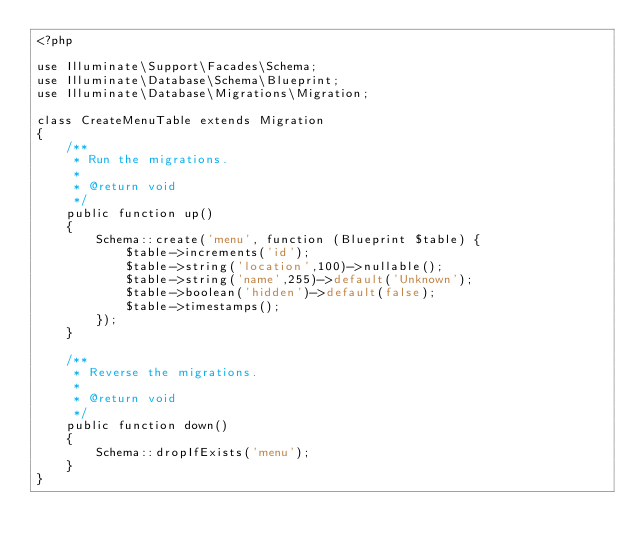Convert code to text. <code><loc_0><loc_0><loc_500><loc_500><_PHP_><?php

use Illuminate\Support\Facades\Schema;
use Illuminate\Database\Schema\Blueprint;
use Illuminate\Database\Migrations\Migration;

class CreateMenuTable extends Migration
{
    /**
     * Run the migrations.
     *
     * @return void
     */
    public function up()
    {
        Schema::create('menu', function (Blueprint $table) {
            $table->increments('id');
            $table->string('location',100)->nullable();
            $table->string('name',255)->default('Unknown');
            $table->boolean('hidden')->default(false);
            $table->timestamps();
        });
    }

    /**
     * Reverse the migrations.
     *
     * @return void
     */
    public function down()
    {
        Schema::dropIfExists('menu');
    }
}
</code> 